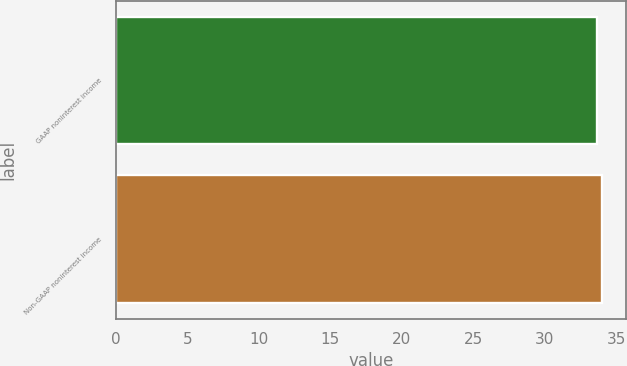<chart> <loc_0><loc_0><loc_500><loc_500><bar_chart><fcel>GAAP noninterest income<fcel>Non-GAAP noninterest income<nl><fcel>33.7<fcel>34<nl></chart> 